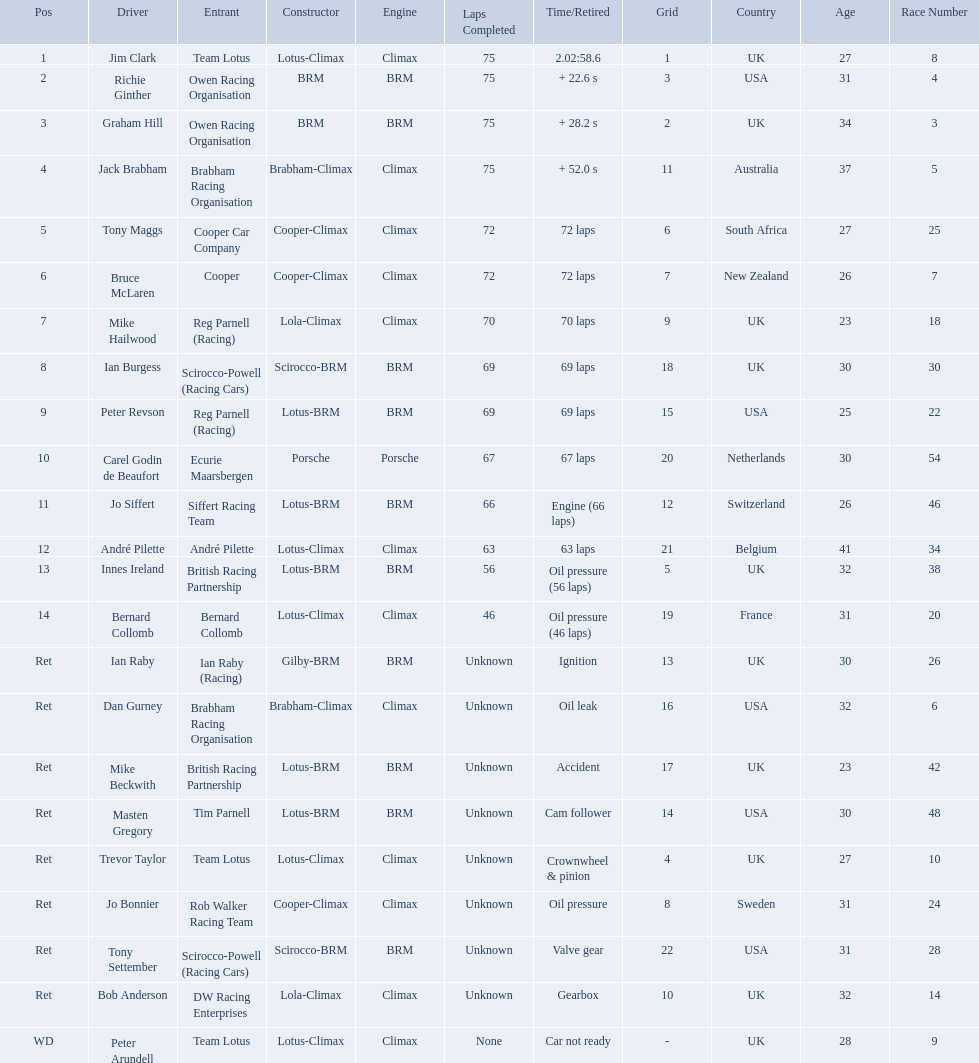Who were the drivers at the 1963 international gold cup? Jim Clark, Richie Ginther, Graham Hill, Jack Brabham, Tony Maggs, Bruce McLaren, Mike Hailwood, Ian Burgess, Peter Revson, Carel Godin de Beaufort, Jo Siffert, André Pilette, Innes Ireland, Bernard Collomb, Ian Raby, Dan Gurney, Mike Beckwith, Masten Gregory, Trevor Taylor, Jo Bonnier, Tony Settember, Bob Anderson, Peter Arundell. What was tony maggs position? 5. What was jo siffert? 11. Who came in earlier? Tony Maggs. Who were the drivers in the the 1963 international gold cup? Jim Clark, Richie Ginther, Graham Hill, Jack Brabham, Tony Maggs, Bruce McLaren, Mike Hailwood, Ian Burgess, Peter Revson, Carel Godin de Beaufort, Jo Siffert, André Pilette, Innes Ireland, Bernard Collomb, Ian Raby, Dan Gurney, Mike Beckwith, Masten Gregory, Trevor Taylor, Jo Bonnier, Tony Settember, Bob Anderson, Peter Arundell. Which drivers drove a cooper-climax car? Tony Maggs, Bruce McLaren, Jo Bonnier. What did these drivers place? 5, 6, Ret. What was the best placing position? 5. Who was the driver with this placing? Tony Maggs. Who drove in the 1963 international gold cup? Jim Clark, Richie Ginther, Graham Hill, Jack Brabham, Tony Maggs, Bruce McLaren, Mike Hailwood, Ian Burgess, Peter Revson, Carel Godin de Beaufort, Jo Siffert, André Pilette, Innes Ireland, Bernard Collomb, Ian Raby, Dan Gurney, Mike Beckwith, Masten Gregory, Trevor Taylor, Jo Bonnier, Tony Settember, Bob Anderson, Peter Arundell. Who had problems during the race? Jo Siffert, Innes Ireland, Bernard Collomb, Ian Raby, Dan Gurney, Mike Beckwith, Masten Gregory, Trevor Taylor, Jo Bonnier, Tony Settember, Bob Anderson, Peter Arundell. Of those who was still able to finish the race? Jo Siffert, Innes Ireland, Bernard Collomb. Of those who faced the same issue? Innes Ireland, Bernard Collomb. What issue did they have? Oil pressure. 